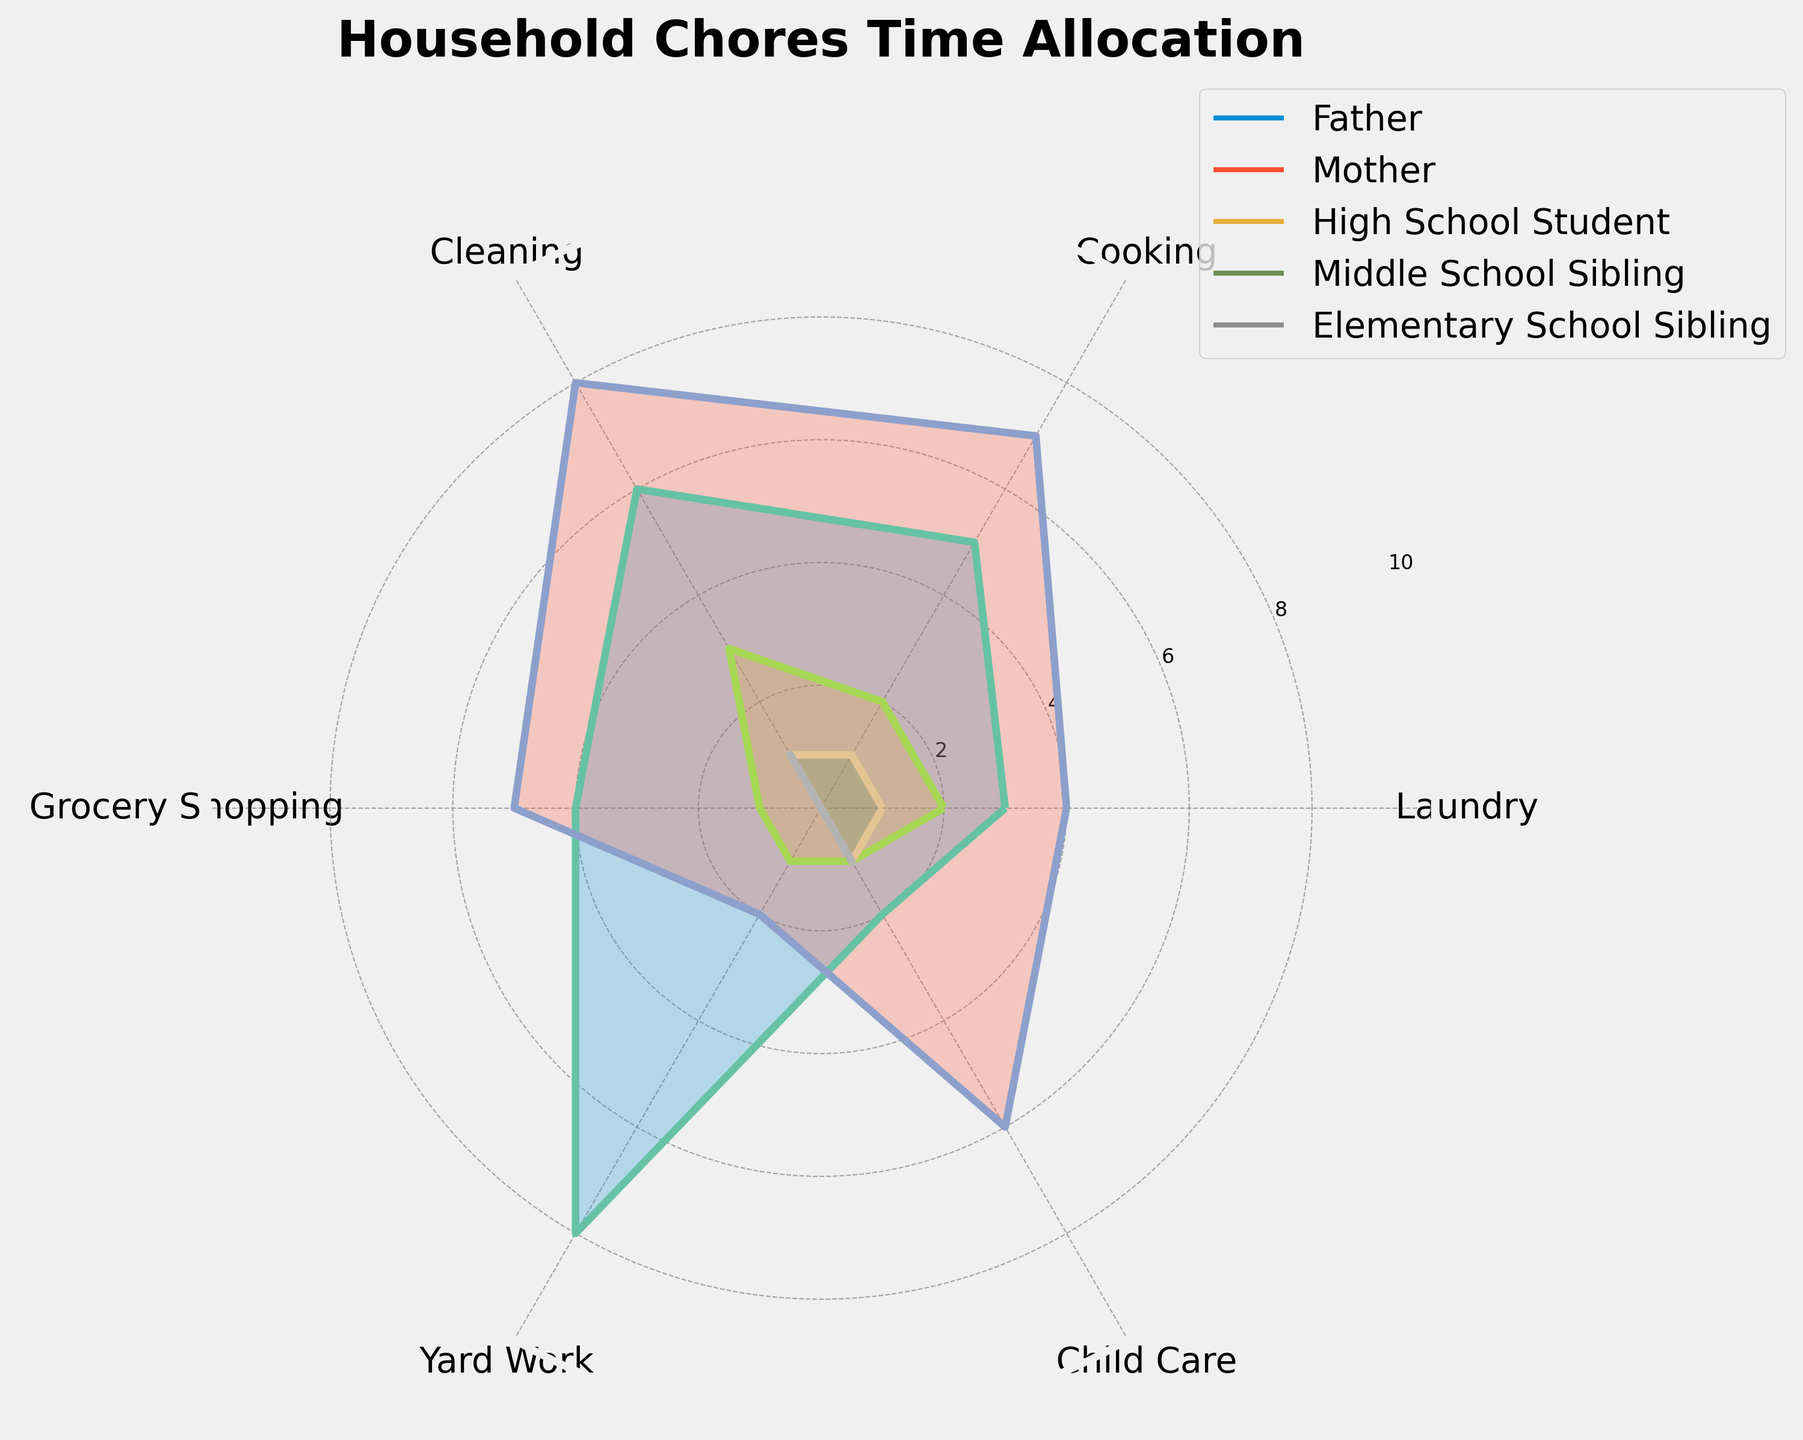What's the title of the figure? The title of the figure is typically placed at the top of the chart and is usually highlighted in a larger font size. It's meant to give an overview of what the chart represents.
Answer: Household Chores Time Allocation How many categories of chores are there? Categories of chores are the labels seen around the circumference of the polar plot, connecting different segments of the chart. You can count the number of distinct labels to determine the total number of categories.
Answer: 6 Which family member spends the most time on cooking? Look at the segment labeled 'Cooking' on the radial axis and identify which family member’s plot has the highest value at this segment.
Answer: Mother What is the average time spent by the Father on all chores? Identify the Father's values for all chores: (3 for Laundry, 5 for Cooking, 6 for Cleaning, 4 for Grocery Shopping, 8 for Yard Work, 2 for Child Care). Calculate the average by summing these values and dividing by the number of chores. (3 + 5 + 6 + 4 + 8 + 2) / 6 = 28 / 6 = 4.67
Answer: 4.67 Which family member spends the least time on yard work? Check the ‘Yard Work’ segment and compare the values. Identify the family member with the lowest value on this segment.
Answer: Middle School Sibling and Elementary School Sibling How much more time does the Mother spend on child care compared to the Father? Look at the values for ‘Child Care’ for both the Mother (6) and the Father (2). Subtract the Father's time from the Mother's time: 6 - 2 = 4
Answer: 4 Who spends equal time on grocery shopping and yard work? Compare the values for both 'Grocery Shopping' and 'Yard Work' for each family member. Find which member has equal values for these two categories.
Answer: High School Student Which chore does the Middle School Sibling spend the most time on? Look at all the segments for the Middle School Sibling and find the segment with the highest value.
Answer: Elementary School Sibling spends the most time on Child Care Is there any family member who spends an equal amount of time on laundry and cooking? Compare the values for 'Laundry' and 'Cooking' for each family member to see if there are any equal values.
Answer: None What is the difference in time spent on cleaning between the Mother and High School Student? Look at the 'Cleaning' segment values for both the Mother (8) and High School Student (3). Subtract the High School Student's time from the Mother's time: 8 - 3 = 5
Answer: 5 